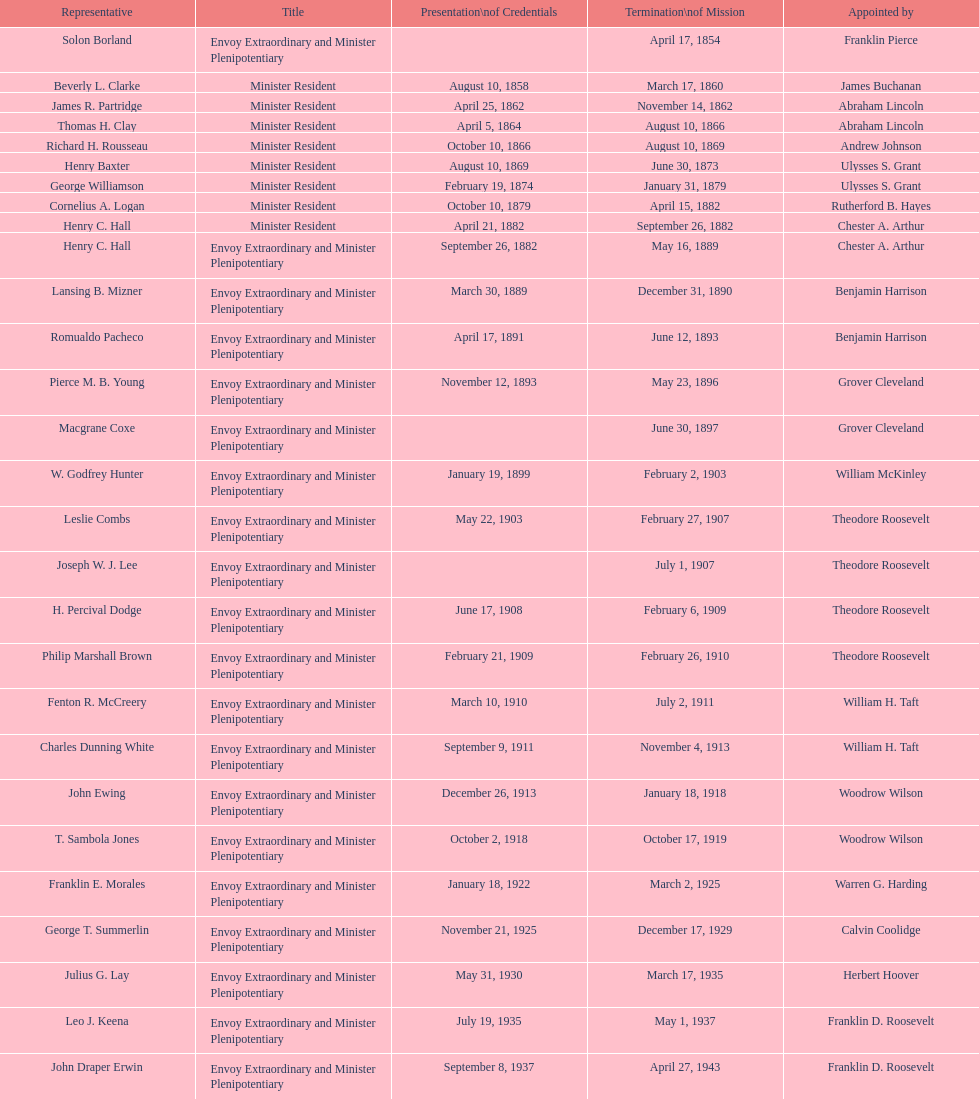How many total representatives have there been? 50. 